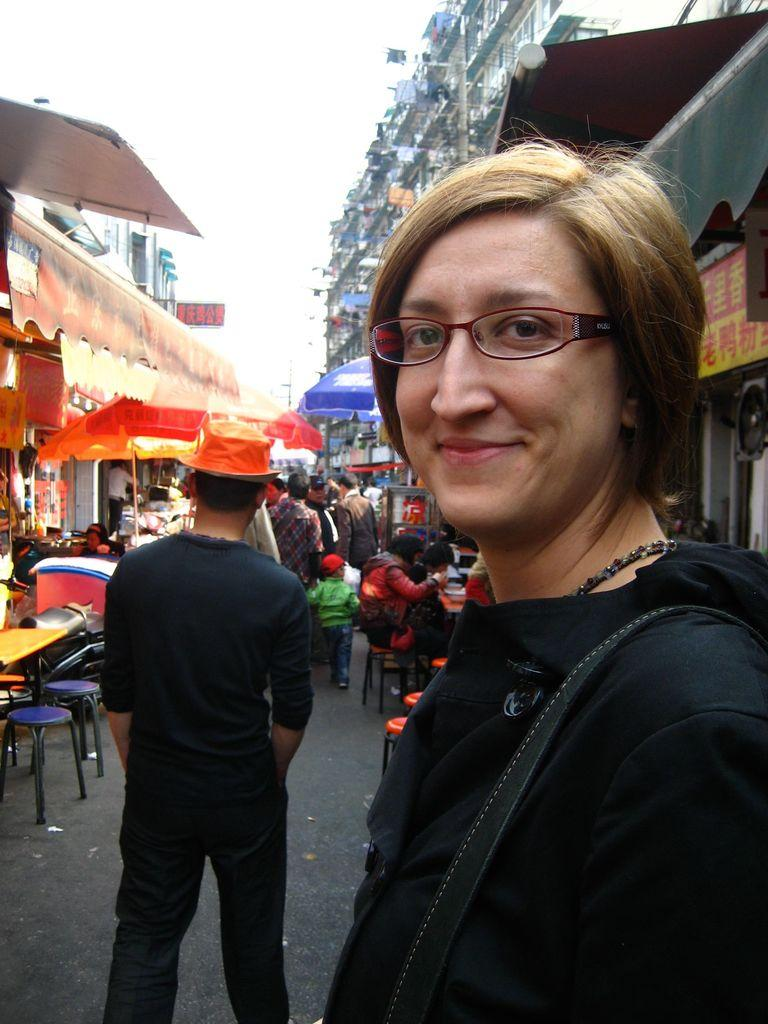How many people are in the image? There is a group of persons in the image, but the exact number cannot be determined from the provided facts. What is the position of the woman in the image? A woman is standing in front of the group in the image. What can be seen in the background of the image? There is a store and a building visible in the background of the image. What type of pies are being sold in the store in the image? There is no information about pies or any store selling them in the image. 